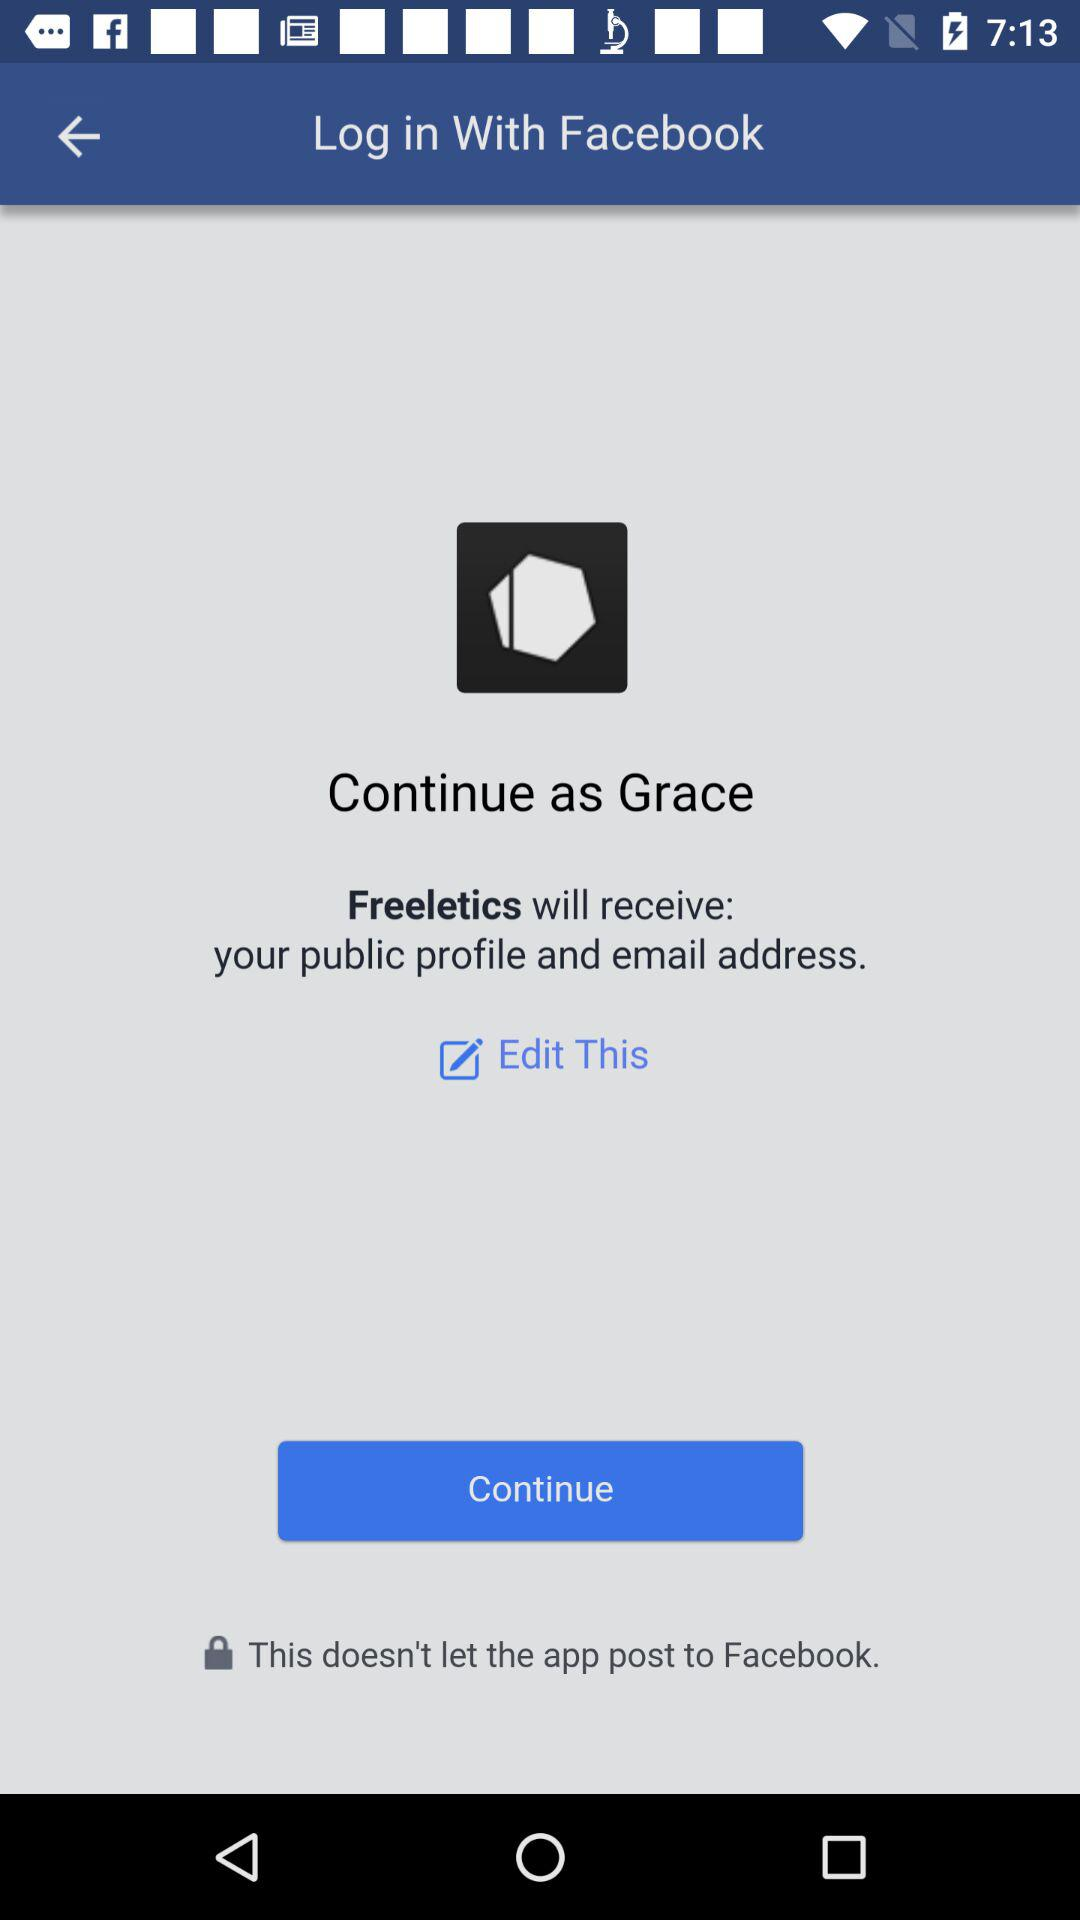Which option is selected?
When the provided information is insufficient, respond with <no answer>. <no answer> 